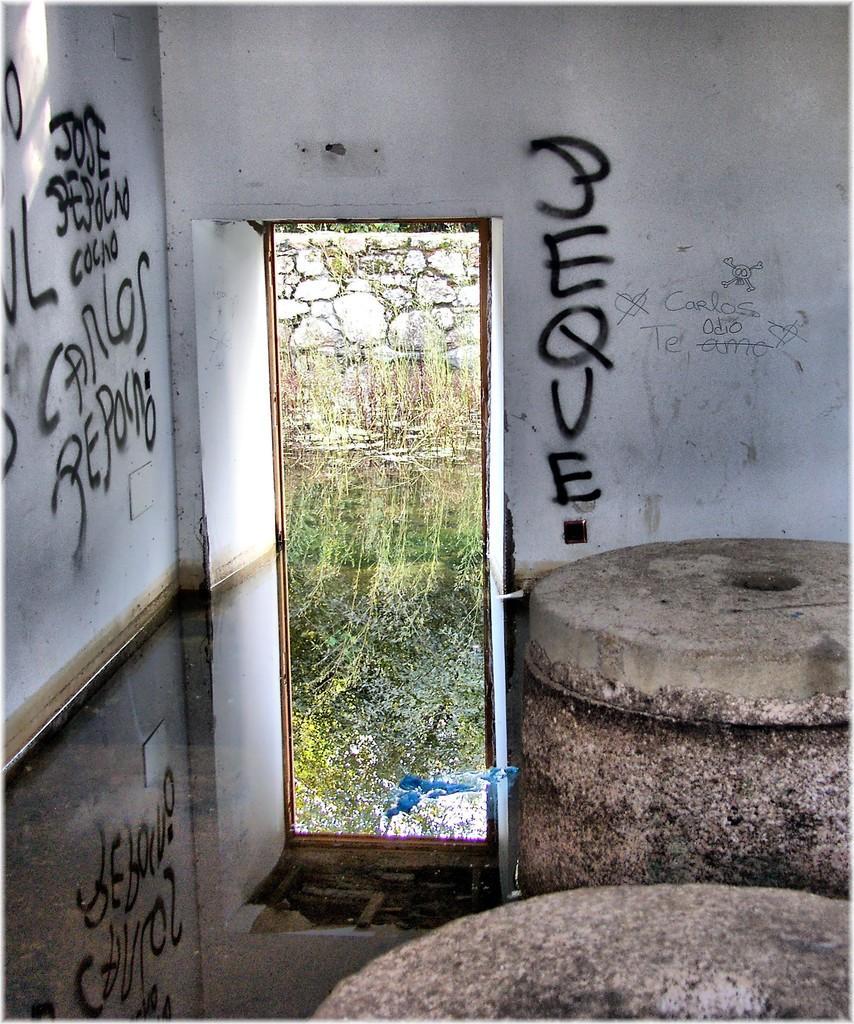Can you describe this image briefly? This image is taken indoors. On the right side of the image there are two concrete objects on the floor. In the middle of the image there are two walls with text on them and there is a way. There are a few plants on the ground. 